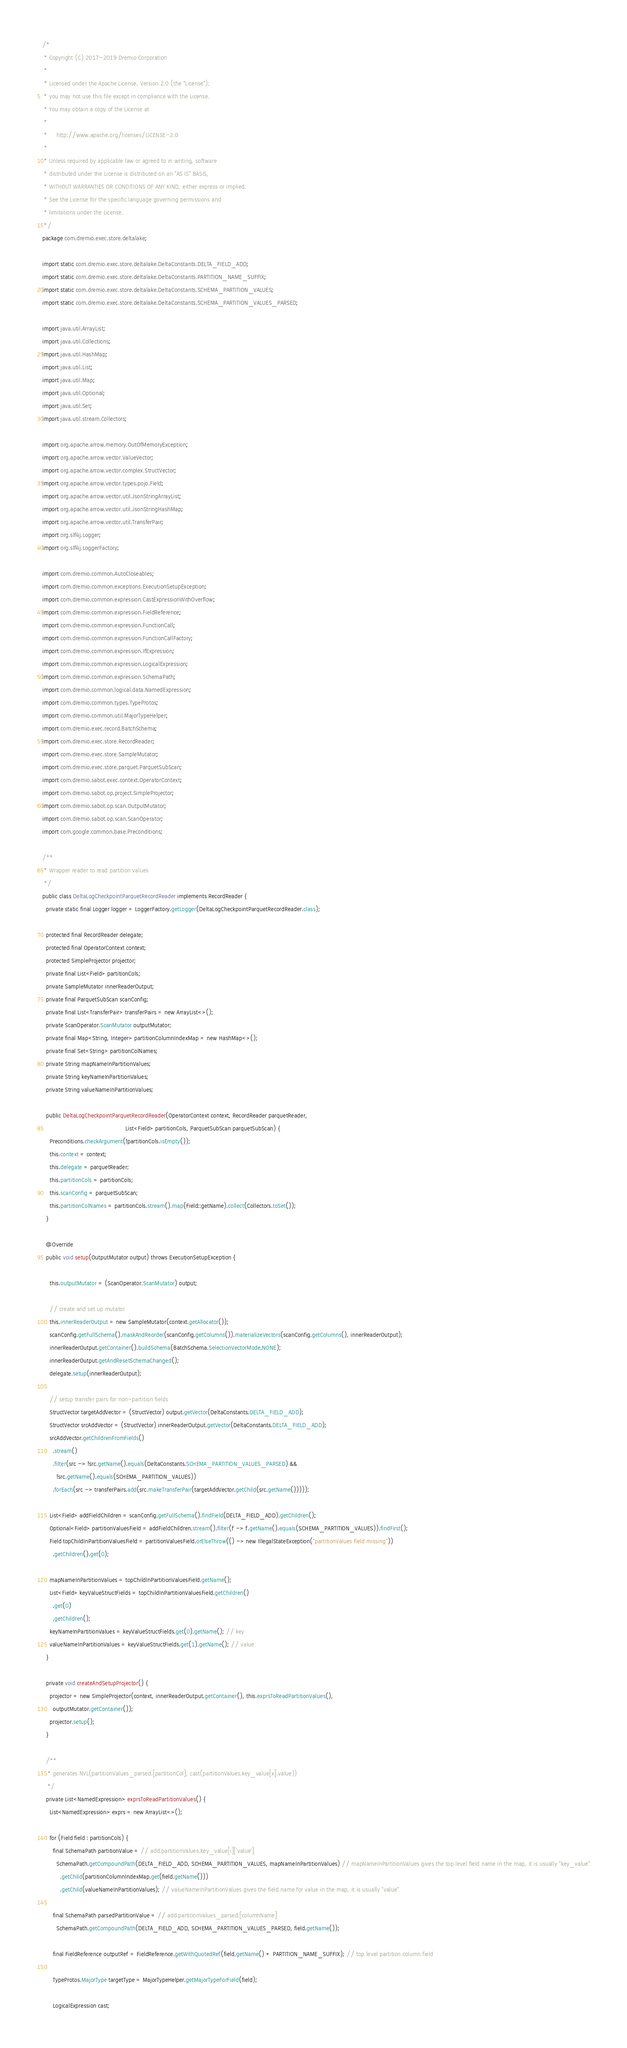Convert code to text. <code><loc_0><loc_0><loc_500><loc_500><_Java_>/*
 * Copyright (C) 2017-2019 Dremio Corporation
 *
 * Licensed under the Apache License, Version 2.0 (the "License");
 * you may not use this file except in compliance with the License.
 * You may obtain a copy of the License at
 *
 *     http://www.apache.org/licenses/LICENSE-2.0
 *
 * Unless required by applicable law or agreed to in writing, software
 * distributed under the License is distributed on an "AS IS" BASIS,
 * WITHOUT WARRANTIES OR CONDITIONS OF ANY KIND, either express or implied.
 * See the License for the specific language governing permissions and
 * limitations under the License.
 */
package com.dremio.exec.store.deltalake;

import static com.dremio.exec.store.deltalake.DeltaConstants.DELTA_FIELD_ADD;
import static com.dremio.exec.store.deltalake.DeltaConstants.PARTITION_NAME_SUFFIX;
import static com.dremio.exec.store.deltalake.DeltaConstants.SCHEMA_PARTITION_VALUES;
import static com.dremio.exec.store.deltalake.DeltaConstants.SCHEMA_PARTITION_VALUES_PARSED;

import java.util.ArrayList;
import java.util.Collections;
import java.util.HashMap;
import java.util.List;
import java.util.Map;
import java.util.Optional;
import java.util.Set;
import java.util.stream.Collectors;

import org.apache.arrow.memory.OutOfMemoryException;
import org.apache.arrow.vector.ValueVector;
import org.apache.arrow.vector.complex.StructVector;
import org.apache.arrow.vector.types.pojo.Field;
import org.apache.arrow.vector.util.JsonStringArrayList;
import org.apache.arrow.vector.util.JsonStringHashMap;
import org.apache.arrow.vector.util.TransferPair;
import org.slf4j.Logger;
import org.slf4j.LoggerFactory;

import com.dremio.common.AutoCloseables;
import com.dremio.common.exceptions.ExecutionSetupException;
import com.dremio.common.expression.CastExpressionWithOverflow;
import com.dremio.common.expression.FieldReference;
import com.dremio.common.expression.FunctionCall;
import com.dremio.common.expression.FunctionCallFactory;
import com.dremio.common.expression.IfExpression;
import com.dremio.common.expression.LogicalExpression;
import com.dremio.common.expression.SchemaPath;
import com.dremio.common.logical.data.NamedExpression;
import com.dremio.common.types.TypeProtos;
import com.dremio.common.util.MajorTypeHelper;
import com.dremio.exec.record.BatchSchema;
import com.dremio.exec.store.RecordReader;
import com.dremio.exec.store.SampleMutator;
import com.dremio.exec.store.parquet.ParquetSubScan;
import com.dremio.sabot.exec.context.OperatorContext;
import com.dremio.sabot.op.project.SimpleProjector;
import com.dremio.sabot.op.scan.OutputMutator;
import com.dremio.sabot.op.scan.ScanOperator;
import com.google.common.base.Preconditions;

/**
 * Wrapper reader to read partition values
 */
public class DeltaLogCheckpointParquetRecordReader implements RecordReader {
  private static final Logger logger = LoggerFactory.getLogger(DeltaLogCheckpointParquetRecordReader.class);

  protected final RecordReader delegate;
  protected final OperatorContext context;
  protected SimpleProjector projector;
  private final List<Field> partitionCols;
  private SampleMutator innerReaderOutput;
  private final ParquetSubScan scanConfig;
  private final List<TransferPair> transferPairs = new ArrayList<>();
  private ScanOperator.ScanMutator outputMutator;
  private final Map<String, Integer> partitionColumnIndexMap = new HashMap<>();
  private final Set<String> partitionColNames;
  private String mapNameInPartitionValues;
  private String keyNameInPartitionValues;
  private String valueNameInPartitionValues;

  public DeltaLogCheckpointParquetRecordReader(OperatorContext context, RecordReader parquetReader,
                                               List<Field> partitionCols, ParquetSubScan parquetSubScan) {
    Preconditions.checkArgument(!partitionCols.isEmpty());
    this.context = context;
    this.delegate = parquetReader;
    this.partitionCols = partitionCols;
    this.scanConfig = parquetSubScan;
    this.partitionColNames = partitionCols.stream().map(Field::getName).collect(Collectors.toSet());
  }

  @Override
  public void setup(OutputMutator output) throws ExecutionSetupException {

    this.outputMutator = (ScanOperator.ScanMutator) output;

    // create and set up mutator
    this.innerReaderOutput = new SampleMutator(context.getAllocator());
    scanConfig.getFullSchema().maskAndReorder(scanConfig.getColumns()).materializeVectors(scanConfig.getColumns(), innerReaderOutput);
    innerReaderOutput.getContainer().buildSchema(BatchSchema.SelectionVectorMode.NONE);
    innerReaderOutput.getAndResetSchemaChanged();
    delegate.setup(innerReaderOutput);

    // setup transfer pairs for non-partition fields
    StructVector targetAddVector = (StructVector) output.getVector(DeltaConstants.DELTA_FIELD_ADD);
    StructVector srcAddVector = (StructVector) innerReaderOutput.getVector(DeltaConstants.DELTA_FIELD_ADD);
    srcAddVector.getChildrenFromFields()
      .stream()
      .filter(src -> !src.getName().equals(DeltaConstants.SCHEMA_PARTITION_VALUES_PARSED) &&
        !src.getName().equals(SCHEMA_PARTITION_VALUES))
      .forEach(src -> transferPairs.add(src.makeTransferPair(targetAddVector.getChild(src.getName()))));

    List<Field> addFieldChildren = scanConfig.getFullSchema().findField(DELTA_FIELD_ADD).getChildren();
    Optional<Field> partitionValuesField = addFieldChildren.stream().filter(f -> f.getName().equals(SCHEMA_PARTITION_VALUES)).findFirst();
    Field topChildInPartitionValuesField = partitionValuesField.orElseThrow(() -> new IllegalStateException("partitionValues field missing"))
      .getChildren().get(0);

    mapNameInPartitionValues = topChildInPartitionValuesField.getName();
    List<Field> keyValueStructFields = topChildInPartitionValuesField.getChildren()
      .get(0)
      .getChildren();
    keyNameInPartitionValues = keyValueStructFields.get(0).getName(); // key
    valueNameInPartitionValues = keyValueStructFields.get(1).getName(); // value
  }

  private void createAndSetupProjector() {
    projector = new SimpleProjector(context, innerReaderOutput.getContainer(), this.exprsToReadPartitionValues(),
      outputMutator.getContainer());
    projector.setup();
  }

  /**
   * generates NVL(partitionValues_parsed.[partitionCol], cast(partitionValues.key_value[x].value))
   */
  private List<NamedExpression> exprsToReadPartitionValues() {
    List<NamedExpression> exprs = new ArrayList<>();

    for (Field field : partitionCols) {
      final SchemaPath partitionValue = // add.partitionValues.key_value[i]['value']
        SchemaPath.getCompoundPath(DELTA_FIELD_ADD, SCHEMA_PARTITION_VALUES, mapNameInPartitionValues) // mapNameInPartitionValues gives the top level field name in the map, it is usually "key_value"
          .getChild(partitionColumnIndexMap.get(field.getName()))
          .getChild(valueNameInPartitionValues); // valueNameInPartitionValues gives the field name for value in the map, it is usually "value"

      final SchemaPath parsedPartitionValue = // add.partitionValues_parsed.[columnName]
        SchemaPath.getCompoundPath(DELTA_FIELD_ADD, SCHEMA_PARTITION_VALUES_PARSED, field.getName());

      final FieldReference outputRef = FieldReference.getWithQuotedRef(field.getName() + PARTITION_NAME_SUFFIX); // top level partition column field

      TypeProtos.MajorType targetType = MajorTypeHelper.getMajorTypeForField(field);

      LogicalExpression cast;</code> 